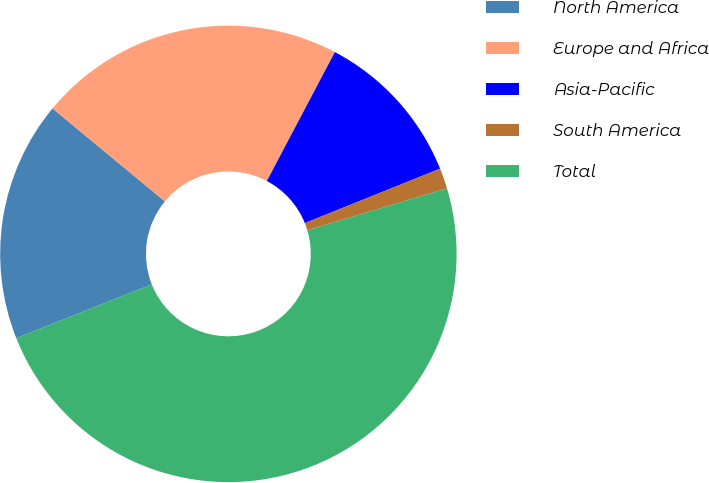<chart> <loc_0><loc_0><loc_500><loc_500><pie_chart><fcel>North America<fcel>Europe and Africa<fcel>Asia-Pacific<fcel>South America<fcel>Total<nl><fcel>17.02%<fcel>21.73%<fcel>11.18%<fcel>1.46%<fcel>48.61%<nl></chart> 